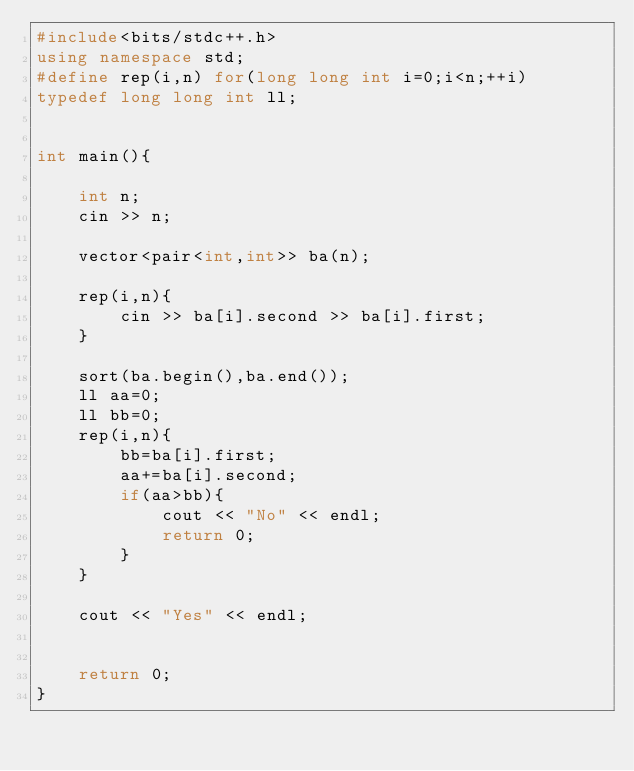<code> <loc_0><loc_0><loc_500><loc_500><_C++_>#include<bits/stdc++.h>
using namespace std;
#define rep(i,n) for(long long int i=0;i<n;++i)
typedef long long int ll;


int main(){

    int n;
    cin >> n;

    vector<pair<int,int>> ba(n);

    rep(i,n){
        cin >> ba[i].second >> ba[i].first;
    }

    sort(ba.begin(),ba.end());
    ll aa=0;
    ll bb=0;
    rep(i,n){
        bb=ba[i].first;
        aa+=ba[i].second;
        if(aa>bb){
            cout << "No" << endl;
            return 0;
        }
    }

    cout << "Yes" << endl;
    

    return 0;
}</code> 